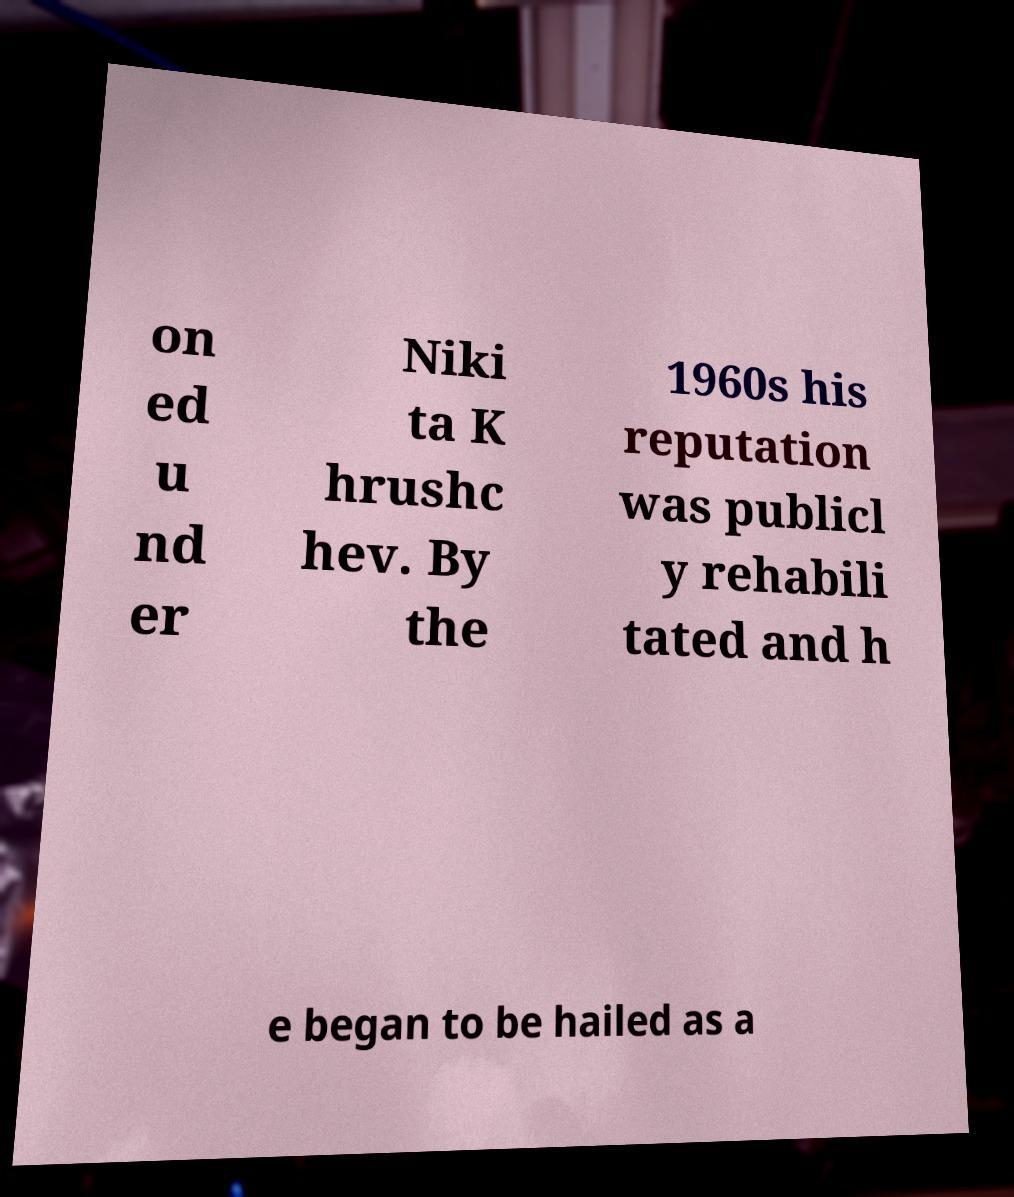What messages or text are displayed in this image? I need them in a readable, typed format. on ed u nd er Niki ta K hrushc hev. By the 1960s his reputation was publicl y rehabili tated and h e began to be hailed as a 